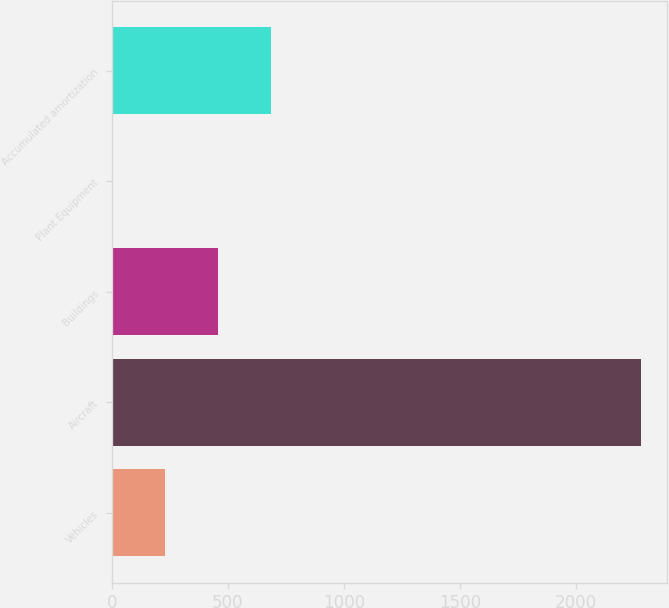<chart> <loc_0><loc_0><loc_500><loc_500><bar_chart><fcel>Vehicles<fcel>Aircraft<fcel>Buildings<fcel>Plant Equipment<fcel>Accumulated amortization<nl><fcel>230<fcel>2282<fcel>458<fcel>2<fcel>686<nl></chart> 